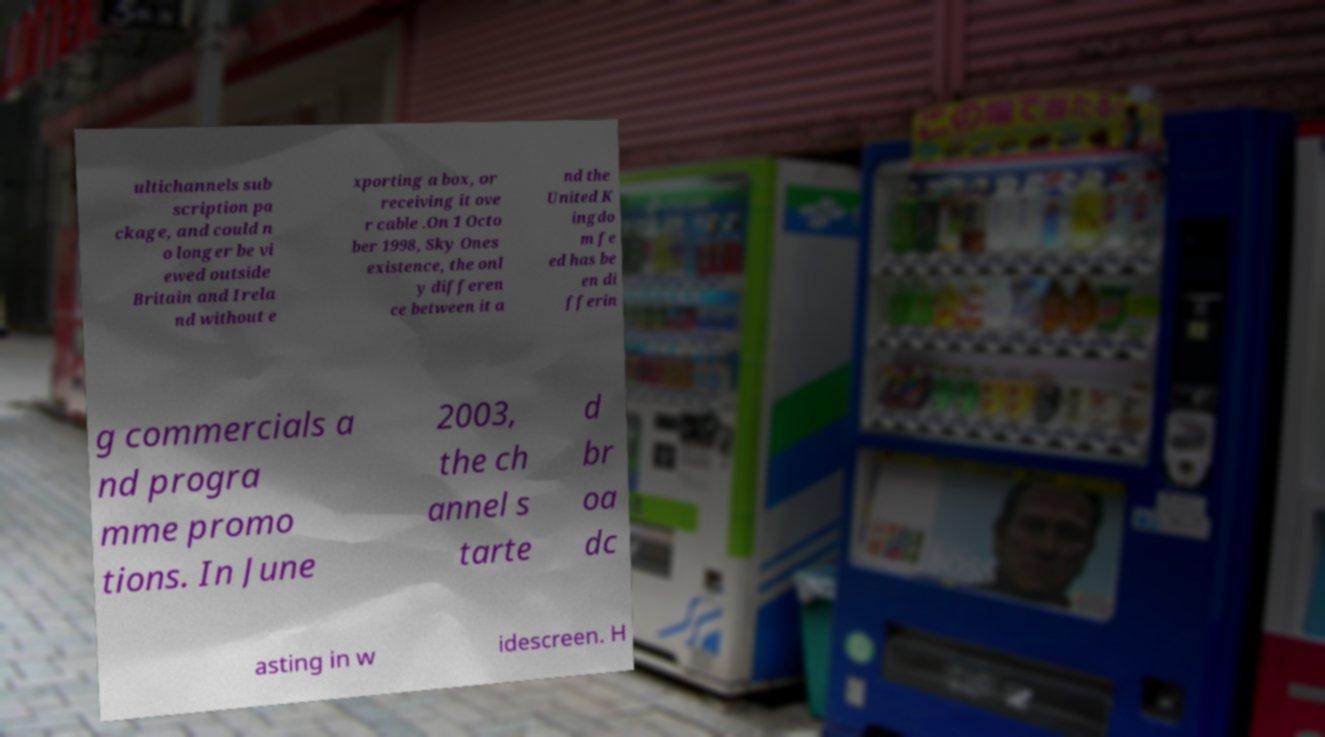What messages or text are displayed in this image? I need them in a readable, typed format. ultichannels sub scription pa ckage, and could n o longer be vi ewed outside Britain and Irela nd without e xporting a box, or receiving it ove r cable .On 1 Octo ber 1998, Sky Ones existence, the onl y differen ce between it a nd the United K ingdo m fe ed has be en di fferin g commercials a nd progra mme promo tions. In June 2003, the ch annel s tarte d br oa dc asting in w idescreen. H 